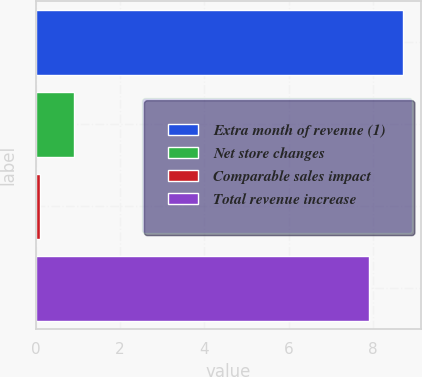Convert chart to OTSL. <chart><loc_0><loc_0><loc_500><loc_500><bar_chart><fcel>Extra month of revenue (1)<fcel>Net store changes<fcel>Comparable sales impact<fcel>Total revenue increase<nl><fcel>8.71<fcel>0.91<fcel>0.1<fcel>7.9<nl></chart> 